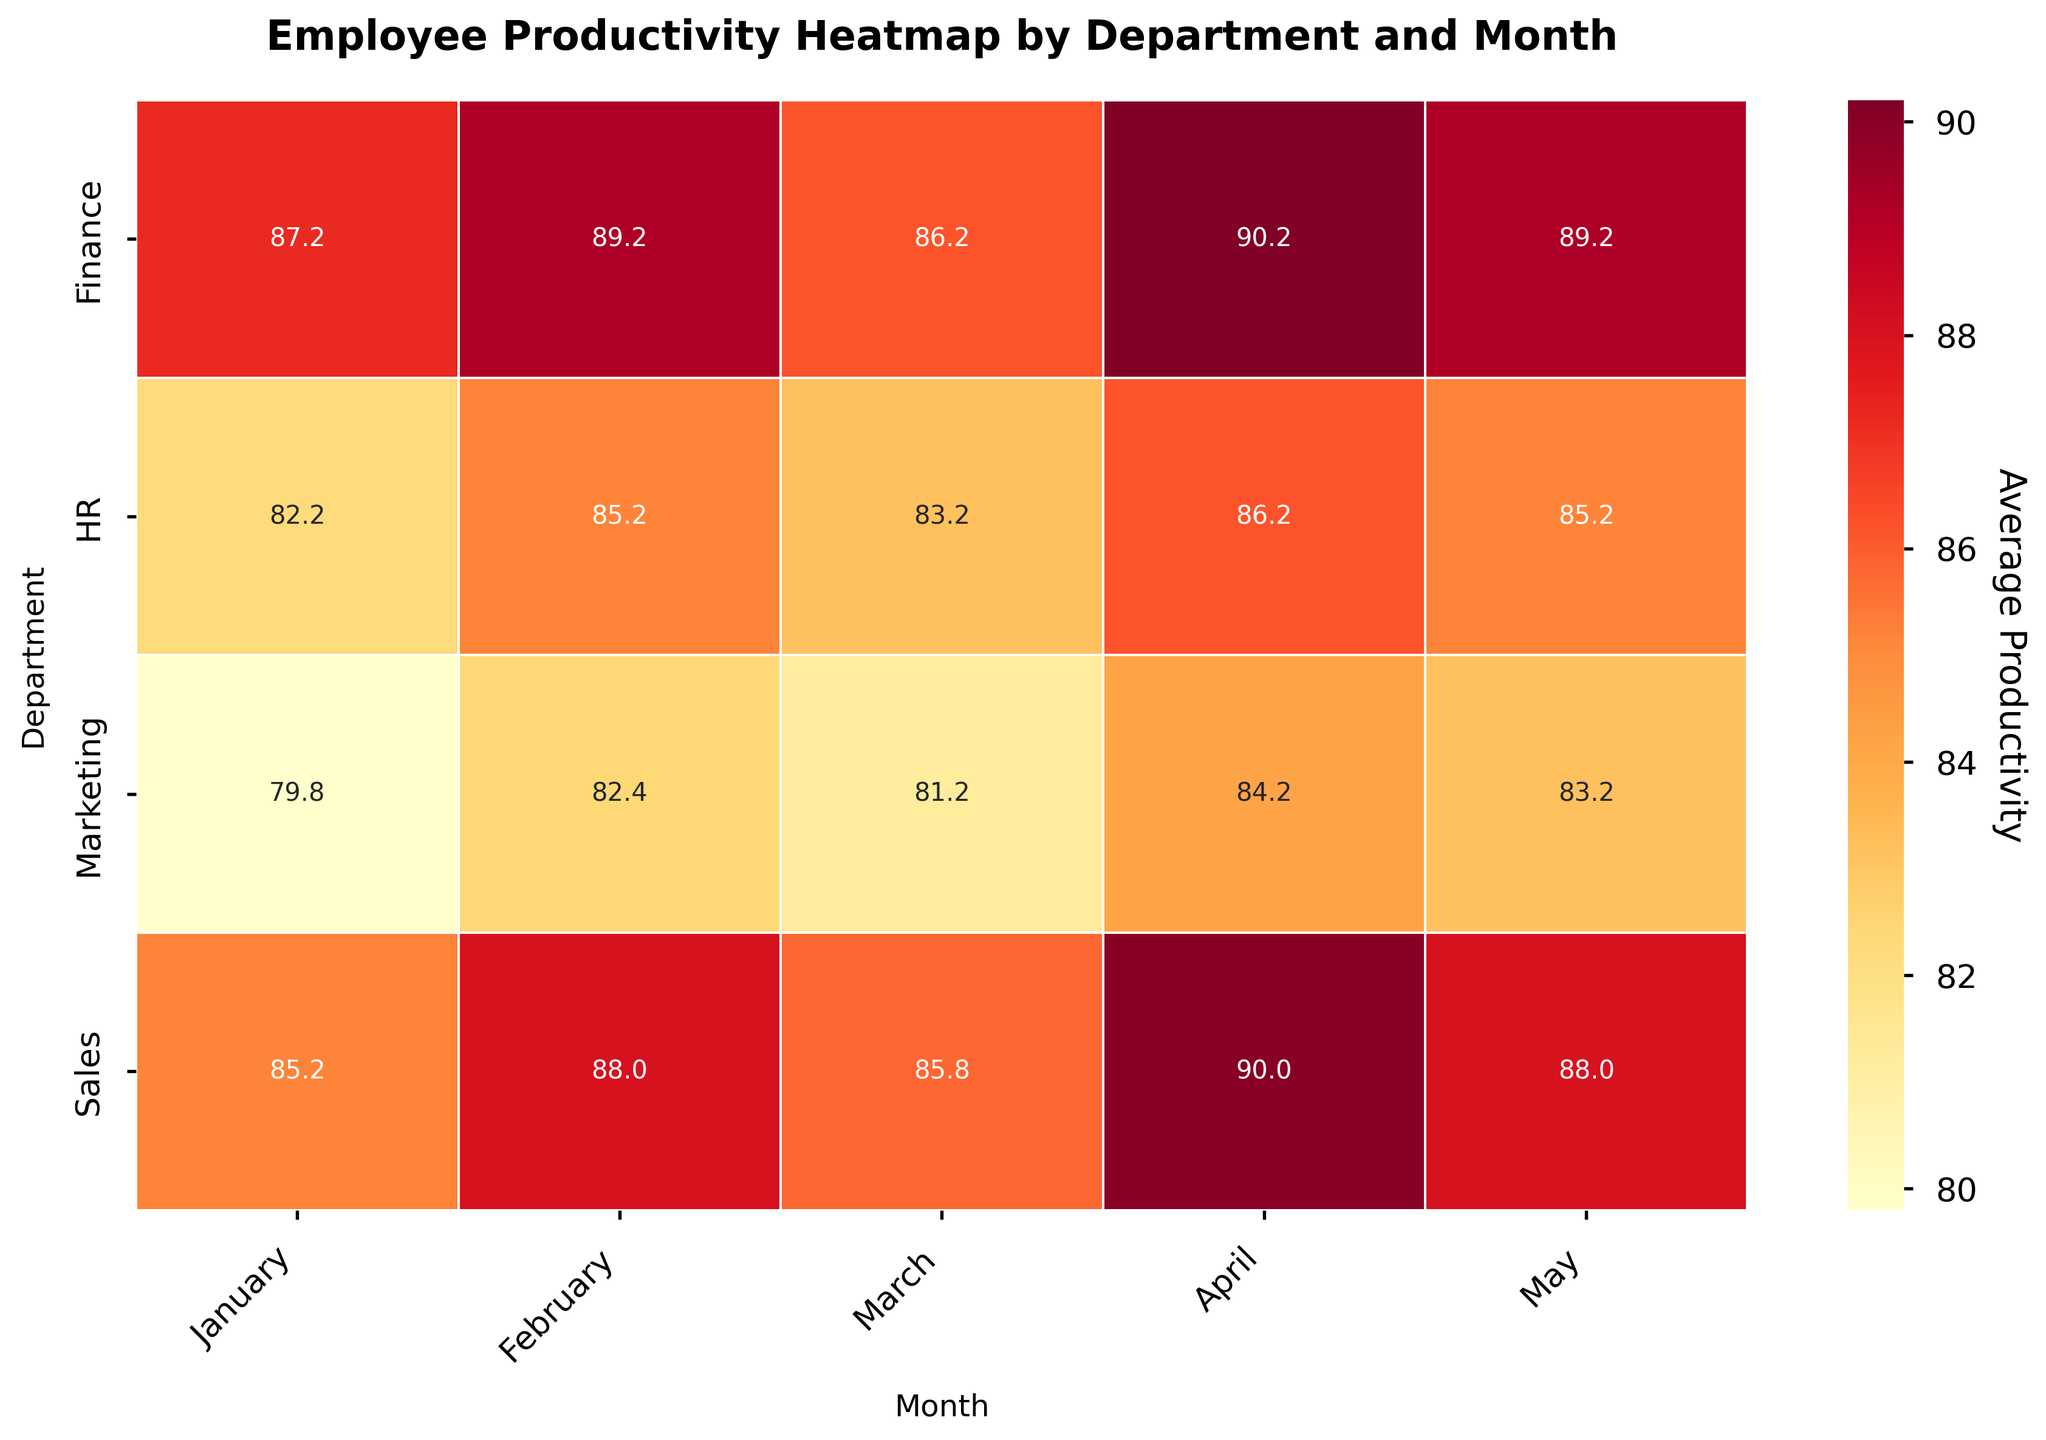What is the title of the heatmap? The title of the heatmap is displayed at the top center of the plot. It reads "Employee Productivity Heatmap by Department and Month".
Answer: Employee Productivity Heatmap by Department and Month Which department has the highest average productivity in April? To find this, locate the column labeled "April" and identify the highest value in that column. The highest value in April is found in the Finance row.
Answer: Finance How does the average productivity of the Sales department in February compare to March? Look at the values for the Sales department in February and March. The average productivity in February is 88, while in March it is 85.
Answer: February is higher What is the average productivity of HR employees in January? Locate the January column and find the value for the HR row. The average productivity of HR employees in January is given in the corresponding cell.
Answer: 82.2 Which month shows the most consistent productivity across all departments? Consistency can be judged by looking at the spread of values in each month column. A month with very similar values across departments indicates consistency. Checking the heatmap, we can see that February has smaller variations across departments.
Answer: February Compare the average productivity of Finance and Marketing departments in May. Look at the May column and compare the values in the Finance and Marketing rows. Finance has an average of 89.2 and Marketing has an average of 83.2.
Answer: Finance is higher Which department experienced the largest increase in average productivity from January to May? Calculate the difference between the January and May values for each department. Find the department with the greatest positive difference. The Sales department increased from 85.2 in January to 88 in May, an increase of 2.8, which is the largest increase.
Answer: Sales Is there any department that shows a decreasing trend in average productivity from January to May? Check each department’s values from January to May. Identify if any department’s values consistently decrease. None of the departments consistently decrease.
Answer: No What is the average productivity across all departments in March? To get the average, sum the March column values for all departments and divide by the number of departments (4). The values are (86.6 + 81.2 + 86.2 + 83.2)/4.
Answer: 84.3 Which month has the highest overall average productivity across all departments? Calculate the average productivity for each month by summing the values of each month column and dividing by the number of departments. Compare the averages to find the highest. April has the highest overall average.
Answer: April 